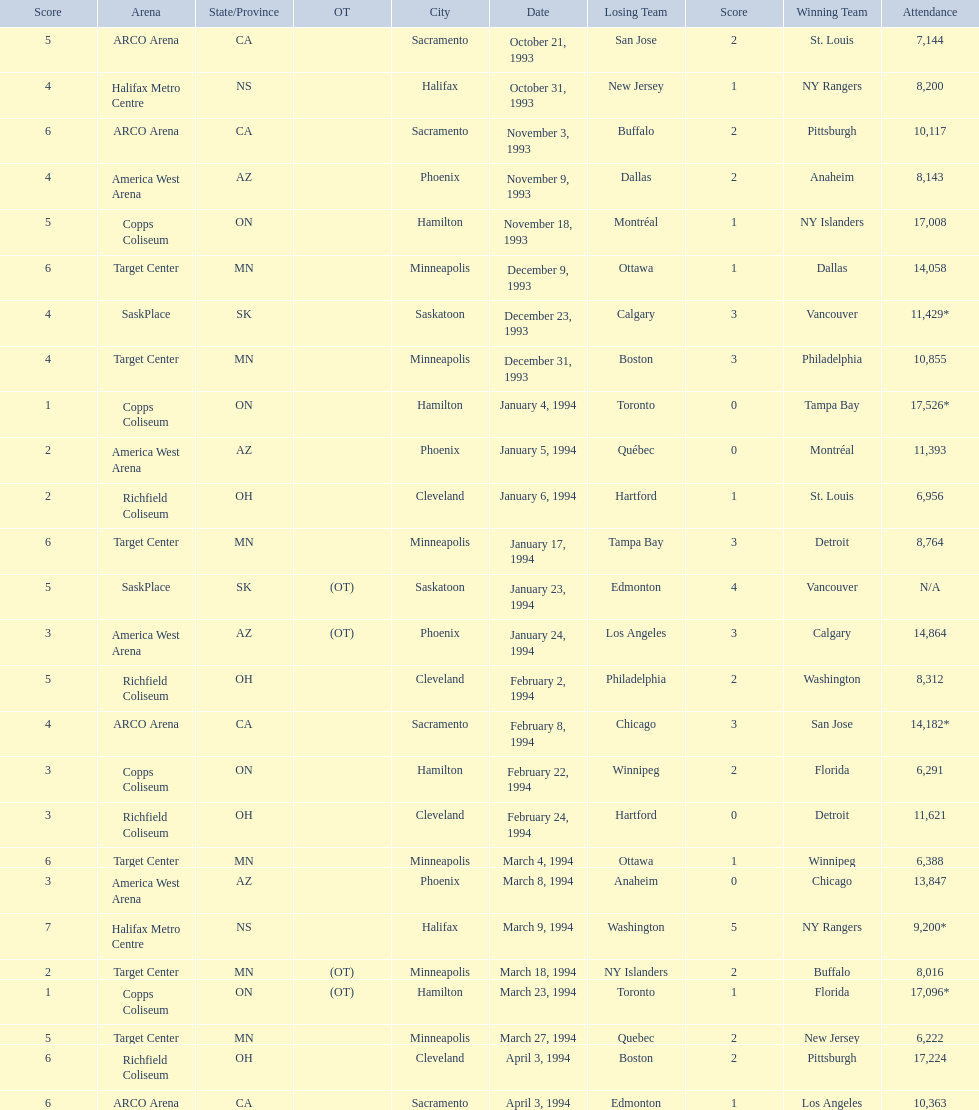Which dates saw the winning team score only one point? January 4, 1994, March 23, 1994. Can you give me this table in json format? {'header': ['Score', 'Arena', 'State/Province', 'OT', 'City', 'Date', 'Losing Team', 'Score', 'Winning Team', 'Attendance'], 'rows': [['5', 'ARCO Arena', 'CA', '', 'Sacramento', 'October 21, 1993', 'San Jose', '2', 'St. Louis', '7,144'], ['4', 'Halifax Metro Centre', 'NS', '', 'Halifax', 'October 31, 1993', 'New Jersey', '1', 'NY Rangers', '8,200'], ['6', 'ARCO Arena', 'CA', '', 'Sacramento', 'November 3, 1993', 'Buffalo', '2', 'Pittsburgh', '10,117'], ['4', 'America West Arena', 'AZ', '', 'Phoenix', 'November 9, 1993', 'Dallas', '2', 'Anaheim', '8,143'], ['5', 'Copps Coliseum', 'ON', '', 'Hamilton', 'November 18, 1993', 'Montréal', '1', 'NY Islanders', '17,008'], ['6', 'Target Center', 'MN', '', 'Minneapolis', 'December 9, 1993', 'Ottawa', '1', 'Dallas', '14,058'], ['4', 'SaskPlace', 'SK', '', 'Saskatoon', 'December 23, 1993', 'Calgary', '3', 'Vancouver', '11,429*'], ['4', 'Target Center', 'MN', '', 'Minneapolis', 'December 31, 1993', 'Boston', '3', 'Philadelphia', '10,855'], ['1', 'Copps Coliseum', 'ON', '', 'Hamilton', 'January 4, 1994', 'Toronto', '0', 'Tampa Bay', '17,526*'], ['2', 'America West Arena', 'AZ', '', 'Phoenix', 'January 5, 1994', 'Québec', '0', 'Montréal', '11,393'], ['2', 'Richfield Coliseum', 'OH', '', 'Cleveland', 'January 6, 1994', 'Hartford', '1', 'St. Louis', '6,956'], ['6', 'Target Center', 'MN', '', 'Minneapolis', 'January 17, 1994', 'Tampa Bay', '3', 'Detroit', '8,764'], ['5', 'SaskPlace', 'SK', '(OT)', 'Saskatoon', 'January 23, 1994', 'Edmonton', '4', 'Vancouver', 'N/A'], ['3', 'America West Arena', 'AZ', '(OT)', 'Phoenix', 'January 24, 1994', 'Los Angeles', '3', 'Calgary', '14,864'], ['5', 'Richfield Coliseum', 'OH', '', 'Cleveland', 'February 2, 1994', 'Philadelphia', '2', 'Washington', '8,312'], ['4', 'ARCO Arena', 'CA', '', 'Sacramento', 'February 8, 1994', 'Chicago', '3', 'San Jose', '14,182*'], ['3', 'Copps Coliseum', 'ON', '', 'Hamilton', 'February 22, 1994', 'Winnipeg', '2', 'Florida', '6,291'], ['3', 'Richfield Coliseum', 'OH', '', 'Cleveland', 'February 24, 1994', 'Hartford', '0', 'Detroit', '11,621'], ['6', 'Target Center', 'MN', '', 'Minneapolis', 'March 4, 1994', 'Ottawa', '1', 'Winnipeg', '6,388'], ['3', 'America West Arena', 'AZ', '', 'Phoenix', 'March 8, 1994', 'Anaheim', '0', 'Chicago', '13,847'], ['7', 'Halifax Metro Centre', 'NS', '', 'Halifax', 'March 9, 1994', 'Washington', '5', 'NY Rangers', '9,200*'], ['2', 'Target Center', 'MN', '(OT)', 'Minneapolis', 'March 18, 1994', 'NY Islanders', '2', 'Buffalo', '8,016'], ['1', 'Copps Coliseum', 'ON', '(OT)', 'Hamilton', 'March 23, 1994', 'Toronto', '1', 'Florida', '17,096*'], ['5', 'Target Center', 'MN', '', 'Minneapolis', 'March 27, 1994', 'Quebec', '2', 'New Jersey', '6,222'], ['6', 'Richfield Coliseum', 'OH', '', 'Cleveland', 'April 3, 1994', 'Boston', '2', 'Pittsburgh', '17,224'], ['6', 'ARCO Arena', 'CA', '', 'Sacramento', 'April 3, 1994', 'Edmonton', '1', 'Los Angeles', '10,363']]} Of these two, which date had higher attendance? January 4, 1994. 